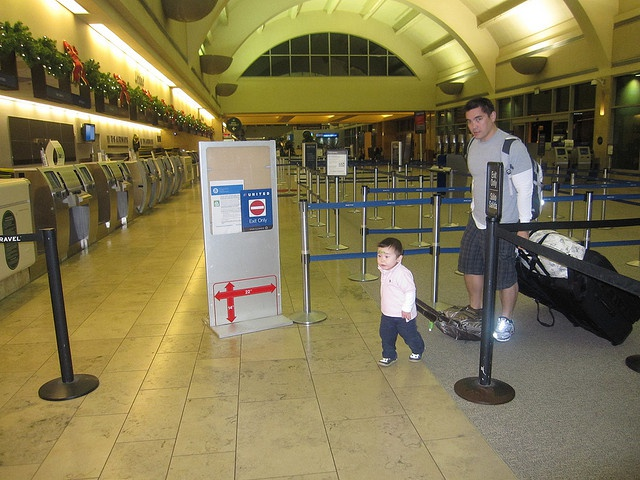Describe the objects in this image and their specific colors. I can see people in tan, darkgray, gray, and black tones, suitcase in tan, black, gray, darkgray, and lightgray tones, people in tan, lavender, gray, black, and darkblue tones, and backpack in tan, gray, darkgray, navy, and darkblue tones in this image. 